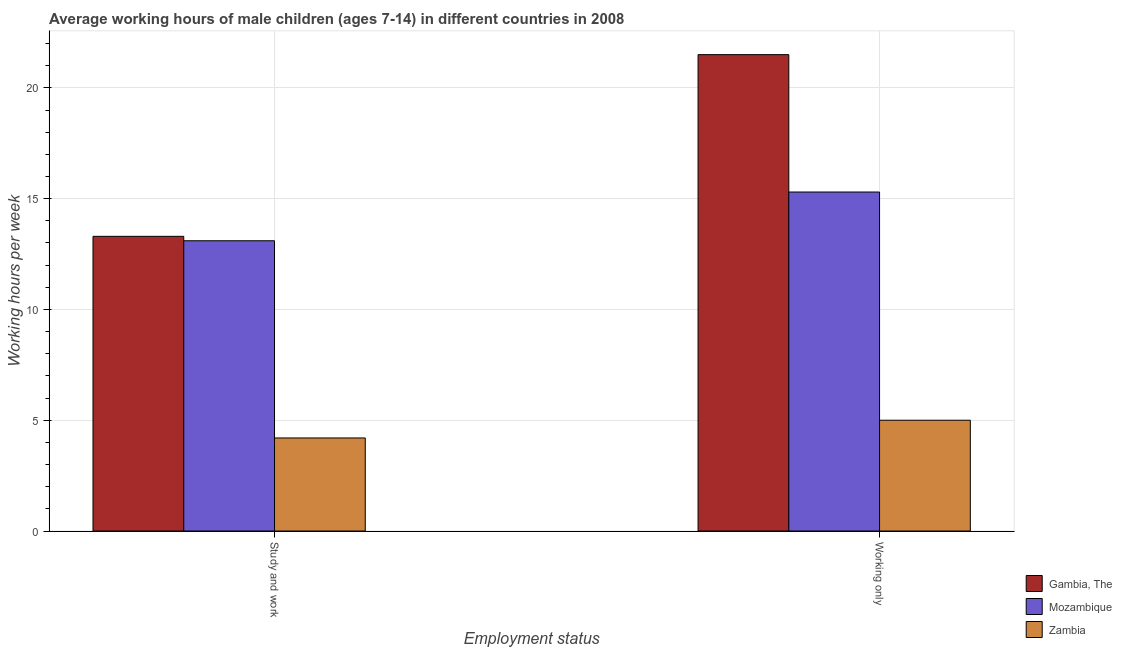How many groups of bars are there?
Provide a short and direct response. 2. Are the number of bars per tick equal to the number of legend labels?
Your answer should be compact. Yes. How many bars are there on the 1st tick from the left?
Your answer should be compact. 3. How many bars are there on the 2nd tick from the right?
Make the answer very short. 3. What is the label of the 2nd group of bars from the left?
Your answer should be very brief. Working only. Across all countries, what is the maximum average working hour of children involved in study and work?
Your answer should be very brief. 13.3. Across all countries, what is the minimum average working hour of children involved in study and work?
Your answer should be compact. 4.2. In which country was the average working hour of children involved in study and work maximum?
Provide a short and direct response. Gambia, The. In which country was the average working hour of children involved in only work minimum?
Provide a succinct answer. Zambia. What is the total average working hour of children involved in only work in the graph?
Ensure brevity in your answer.  41.8. What is the difference between the average working hour of children involved in only work in Zambia and that in Gambia, The?
Offer a terse response. -16.5. What is the difference between the average working hour of children involved in only work in Gambia, The and the average working hour of children involved in study and work in Mozambique?
Offer a terse response. 8.4. What is the difference between the average working hour of children involved in study and work and average working hour of children involved in only work in Gambia, The?
Your answer should be very brief. -8.2. In how many countries, is the average working hour of children involved in study and work greater than 13 hours?
Make the answer very short. 2. What is the ratio of the average working hour of children involved in study and work in Gambia, The to that in Zambia?
Your answer should be very brief. 3.17. What does the 1st bar from the left in Study and work represents?
Give a very brief answer. Gambia, The. What does the 3rd bar from the right in Working only represents?
Offer a very short reply. Gambia, The. How many countries are there in the graph?
Provide a succinct answer. 3. What is the difference between two consecutive major ticks on the Y-axis?
Make the answer very short. 5. Are the values on the major ticks of Y-axis written in scientific E-notation?
Offer a terse response. No. Does the graph contain any zero values?
Your answer should be very brief. No. Does the graph contain grids?
Ensure brevity in your answer.  Yes. Where does the legend appear in the graph?
Give a very brief answer. Bottom right. How are the legend labels stacked?
Ensure brevity in your answer.  Vertical. What is the title of the graph?
Your response must be concise. Average working hours of male children (ages 7-14) in different countries in 2008. What is the label or title of the X-axis?
Your answer should be very brief. Employment status. What is the label or title of the Y-axis?
Keep it short and to the point. Working hours per week. Across all Employment status, what is the maximum Working hours per week in Gambia, The?
Offer a very short reply. 21.5. Across all Employment status, what is the maximum Working hours per week in Zambia?
Offer a terse response. 5. What is the total Working hours per week in Gambia, The in the graph?
Make the answer very short. 34.8. What is the total Working hours per week of Mozambique in the graph?
Offer a very short reply. 28.4. What is the total Working hours per week of Zambia in the graph?
Offer a terse response. 9.2. What is the difference between the Working hours per week of Gambia, The in Study and work and the Working hours per week of Mozambique in Working only?
Provide a succinct answer. -2. What is the difference between the Working hours per week of Mozambique in Study and work and the Working hours per week of Zambia in Working only?
Keep it short and to the point. 8.1. What is the difference between the Working hours per week of Gambia, The and Working hours per week of Zambia in Study and work?
Keep it short and to the point. 9.1. What is the difference between the Working hours per week of Gambia, The and Working hours per week of Mozambique in Working only?
Offer a very short reply. 6.2. What is the difference between the Working hours per week in Gambia, The and Working hours per week in Zambia in Working only?
Your answer should be compact. 16.5. What is the ratio of the Working hours per week of Gambia, The in Study and work to that in Working only?
Keep it short and to the point. 0.62. What is the ratio of the Working hours per week in Mozambique in Study and work to that in Working only?
Ensure brevity in your answer.  0.86. What is the ratio of the Working hours per week of Zambia in Study and work to that in Working only?
Provide a short and direct response. 0.84. What is the difference between the highest and the second highest Working hours per week of Gambia, The?
Your answer should be compact. 8.2. What is the difference between the highest and the second highest Working hours per week of Mozambique?
Your answer should be very brief. 2.2. What is the difference between the highest and the lowest Working hours per week of Mozambique?
Your answer should be compact. 2.2. 